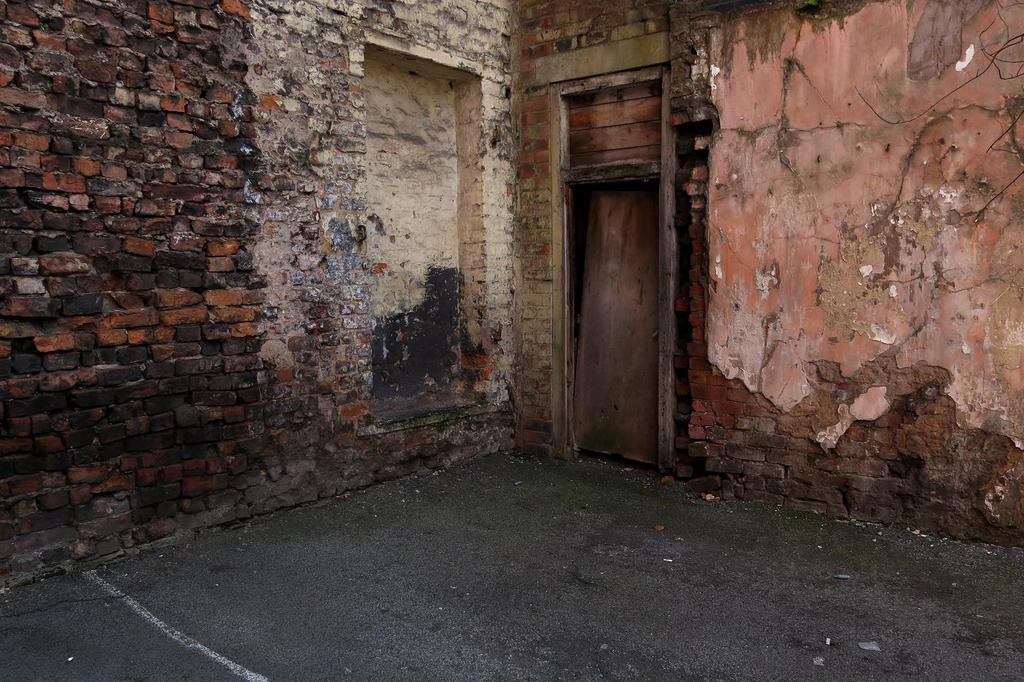What type of wall is visible in the image? There is a brick wall in the image. What type of door is present in the image? There is a wooden door in the image. What year is depicted on the school hall's sign in the image? There is no school hall or sign present in the image; it only features a brick wall and a wooden door. 